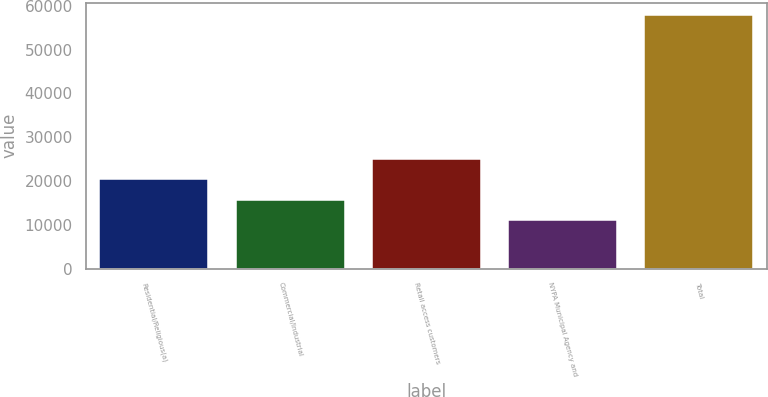Convert chart to OTSL. <chart><loc_0><loc_0><loc_500><loc_500><bar_chart><fcel>Residential/Religious(a)<fcel>Commercial/Industrial<fcel>Retail access customers<fcel>NYPA Municipal Agency and<fcel>Total<nl><fcel>20397.2<fcel>15718.6<fcel>25075.8<fcel>11040<fcel>57826<nl></chart> 